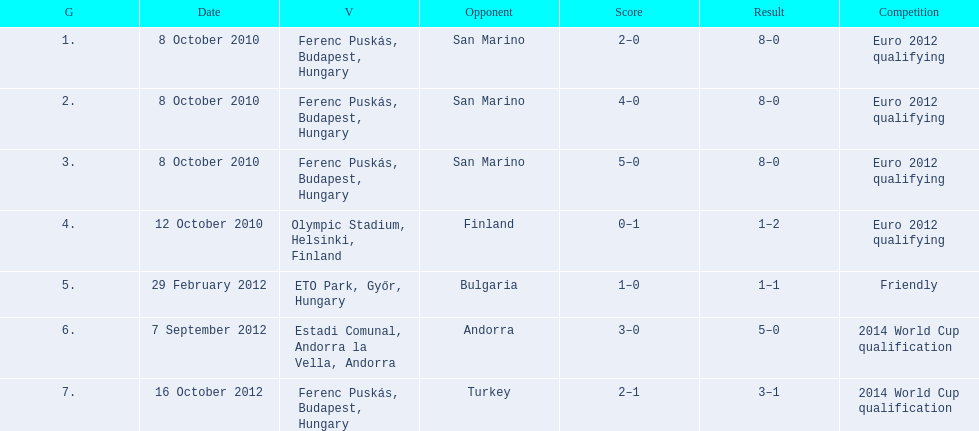How many consecutive games were goals were against san marino? 3. 